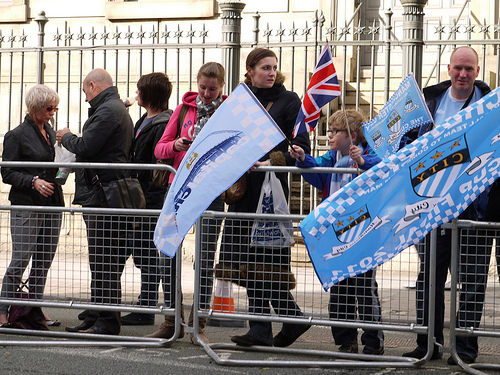<image>
Is the woman behind the fence? No. The woman is not behind the fence. From this viewpoint, the woman appears to be positioned elsewhere in the scene. 